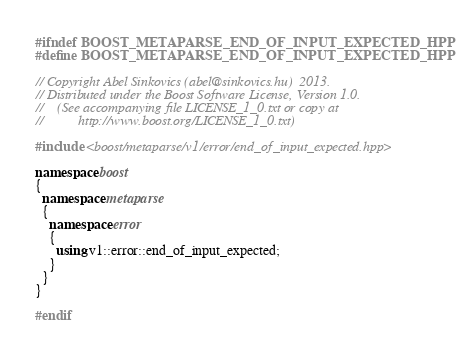<code> <loc_0><loc_0><loc_500><loc_500><_C++_>#ifndef BOOST_METAPARSE_END_OF_INPUT_EXPECTED_HPP
#define BOOST_METAPARSE_END_OF_INPUT_EXPECTED_HPP

// Copyright Abel Sinkovics (abel@sinkovics.hu)  2013.
// Distributed under the Boost Software License, Version 1.0.
//    (See accompanying file LICENSE_1_0.txt or copy at
//          http://www.boost.org/LICENSE_1_0.txt)

#include <boost/metaparse/v1/error/end_of_input_expected.hpp>

namespace boost
{
  namespace metaparse
  {
    namespace error
    {
      using v1::error::end_of_input_expected;
    }
  }
}

#endif
</code> 